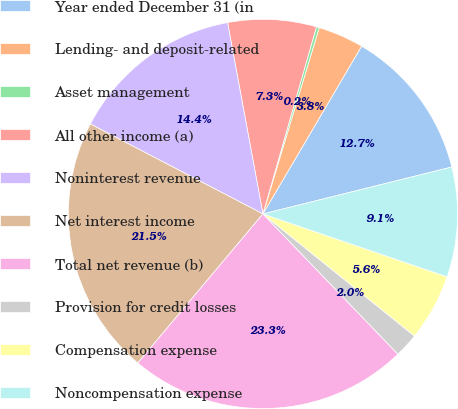Convert chart to OTSL. <chart><loc_0><loc_0><loc_500><loc_500><pie_chart><fcel>Year ended December 31 (in<fcel>Lending- and deposit-related<fcel>Asset management<fcel>All other income (a)<fcel>Noninterest revenue<fcel>Net interest income<fcel>Total net revenue (b)<fcel>Provision for credit losses<fcel>Compensation expense<fcel>Noncompensation expense<nl><fcel>12.66%<fcel>3.79%<fcel>0.24%<fcel>7.34%<fcel>14.44%<fcel>21.53%<fcel>23.31%<fcel>2.01%<fcel>5.56%<fcel>9.11%<nl></chart> 